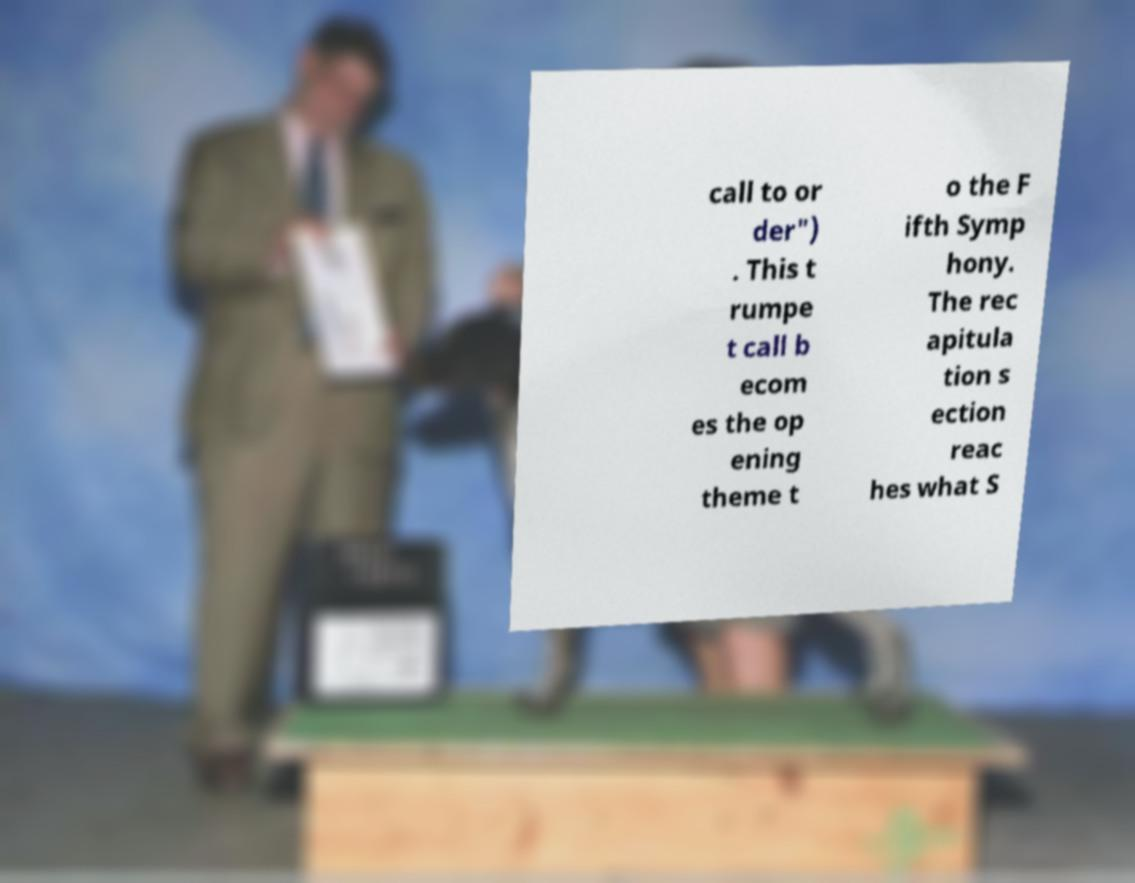What messages or text are displayed in this image? I need them in a readable, typed format. call to or der") . This t rumpe t call b ecom es the op ening theme t o the F ifth Symp hony. The rec apitula tion s ection reac hes what S 